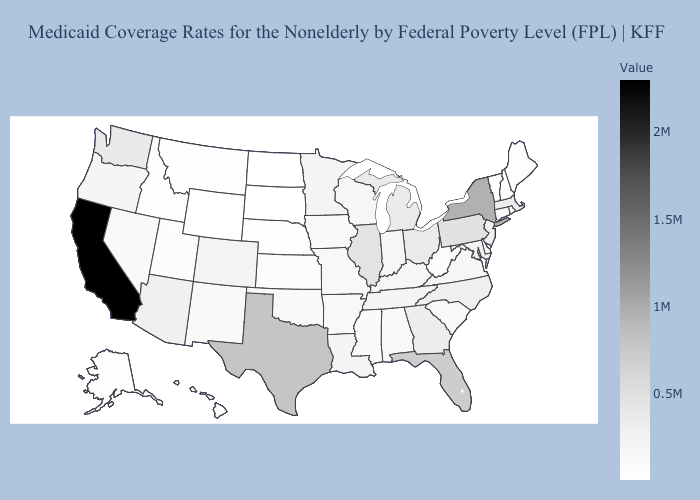Does Oklahoma have the highest value in the South?
Be succinct. No. Among the states that border Maryland , does Delaware have the lowest value?
Quick response, please. Yes. Among the states that border West Virginia , which have the highest value?
Write a very short answer. Pennsylvania. Among the states that border Rhode Island , does Connecticut have the lowest value?
Write a very short answer. Yes. Among the states that border Massachusetts , which have the highest value?
Answer briefly. New York. 